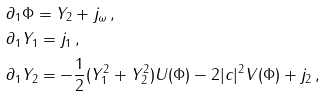<formula> <loc_0><loc_0><loc_500><loc_500>& \partial _ { 1 } \Phi = Y _ { 2 } + j _ { \omega } \, , \\ & \partial _ { 1 } Y _ { 1 } = j _ { 1 } \, , \\ & \partial _ { 1 } Y _ { 2 } = - \frac { 1 } { 2 } ( Y _ { 1 } ^ { 2 } + Y _ { 2 } ^ { 2 } ) U ( \Phi ) - 2 | c | ^ { 2 } V ( \Phi ) + j _ { 2 } \, ,</formula> 